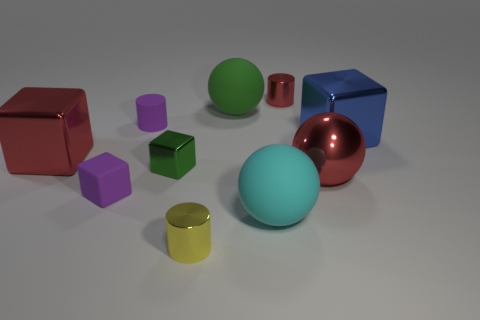Which objects in the image appear to be reflective? In the image, both the red sphere and the blue cube exhibit reflective surfaces, indicating they might be made of materials like polished metal or glass. 